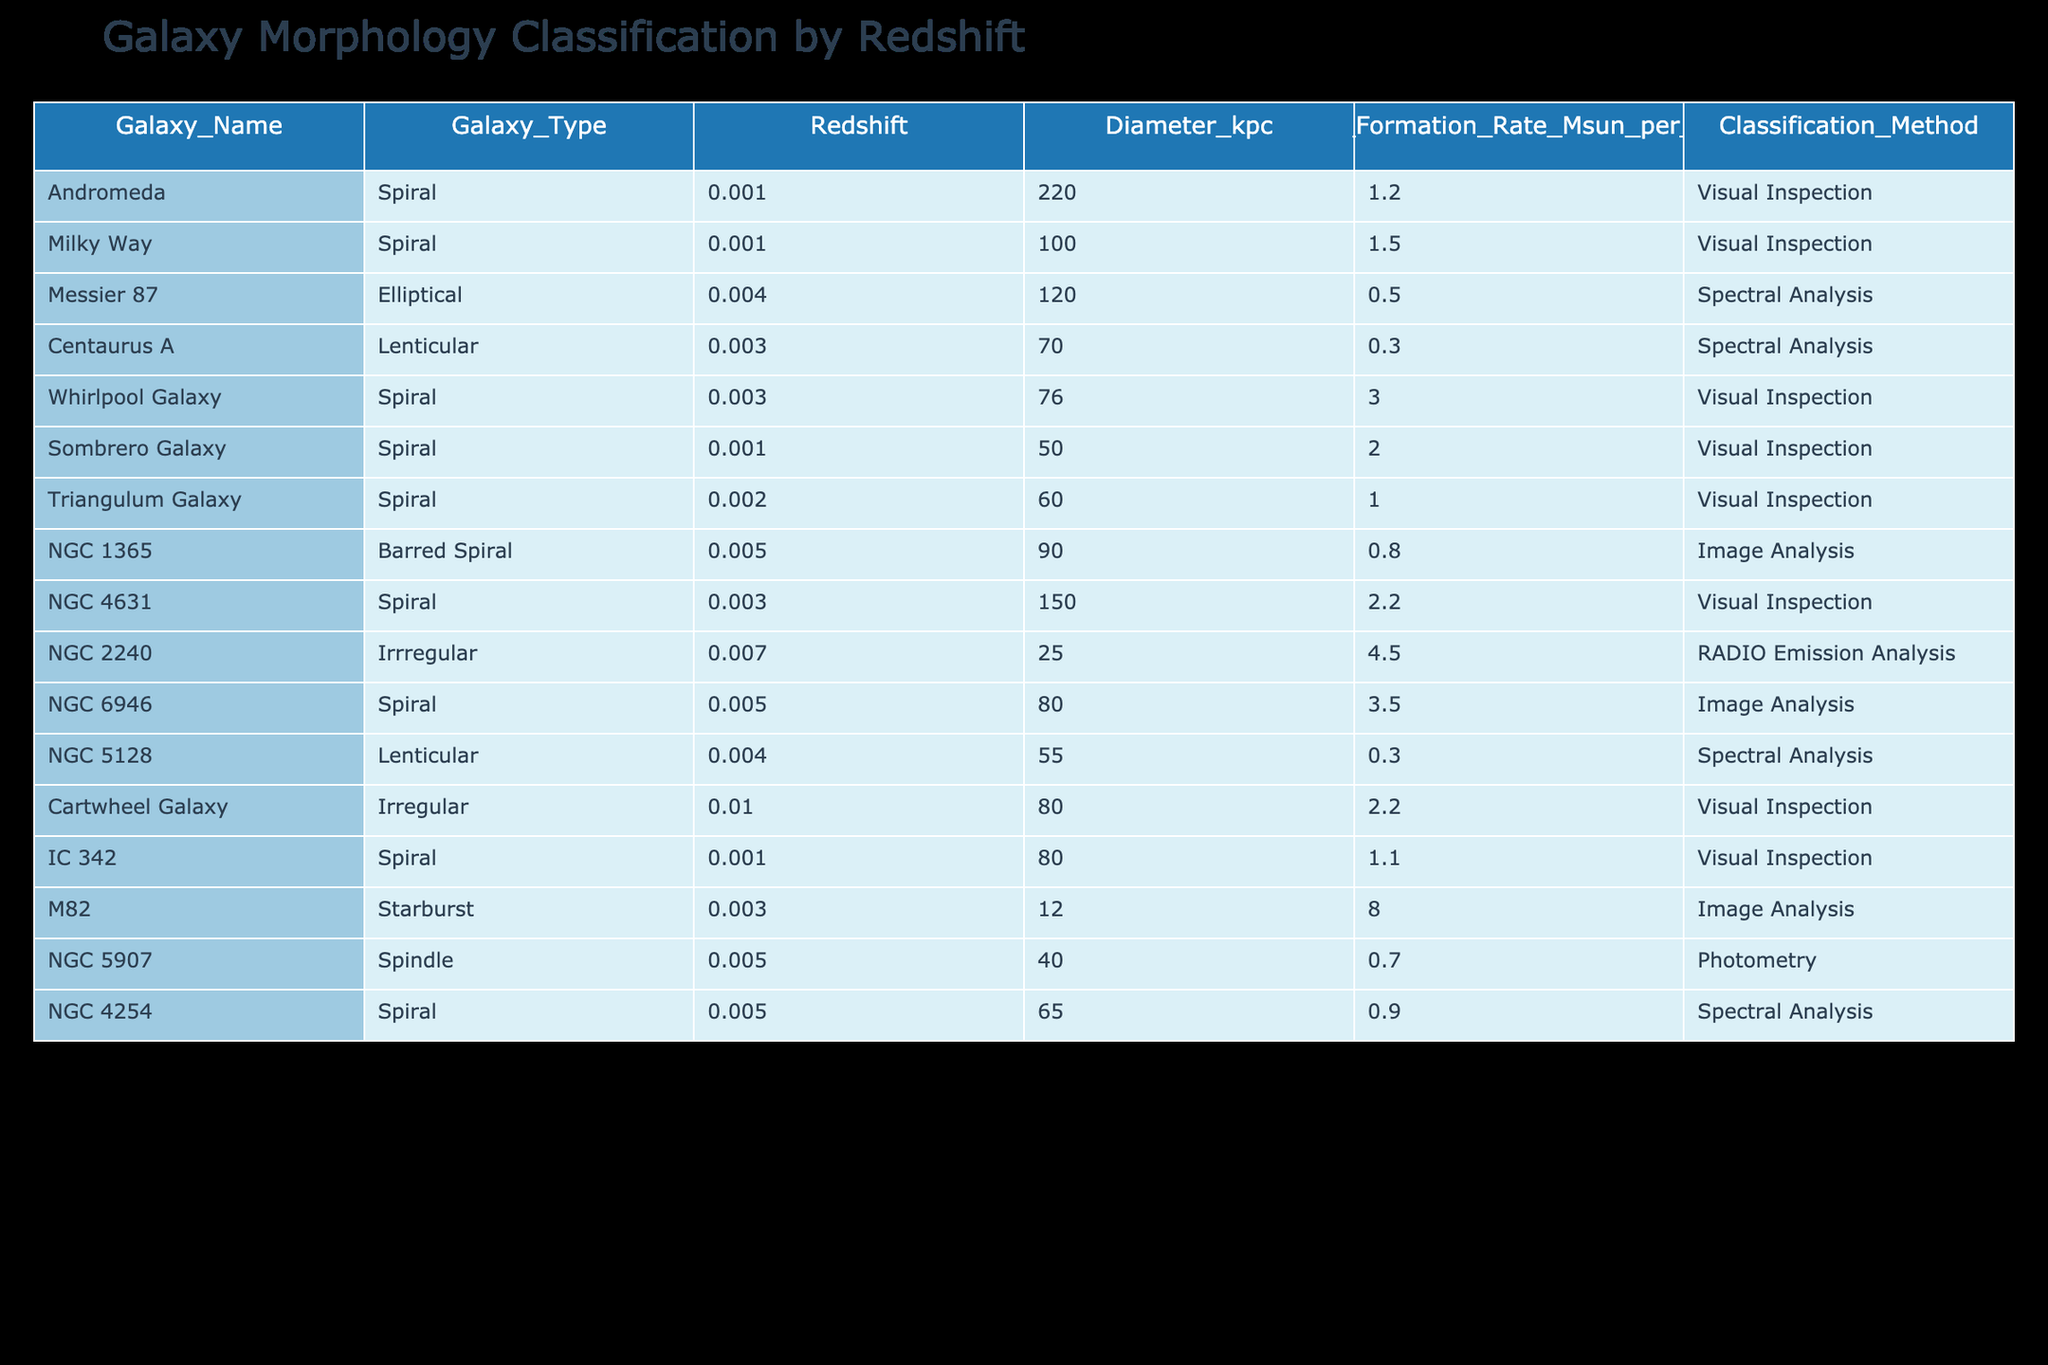What types of galaxies are present in the table? The table lists various galaxy types including Spiral, Elliptical, Lenticular, Barred Spiral, Irregular, Starburst, and Spindle. By scanning the 'Galaxy_Type' column, we can confirm these classifications.
Answer: Spiral, Elliptical, Lenticular, Barred Spiral, Irregular, Starburst, Spindle Which galaxy has the highest star formation rate? The 'Star_Formation_Rate_Msun_per_year' column shows the rates for each galaxy. By comparing the values, M82 with 8.0 has the highest star formation rate among the entries in the table.
Answer: M82 What is the average diameter of Spiral galaxies listed in the table? To determine this, we first gather the diameters of all Spiral galaxies (220, 100, 76, 60, 150, 80, 80, 65), which sums to 811. Since there are 8 Spiral galaxies, the average diameter is calculated as 811/8 = 101.375 kpc.
Answer: 101.375 kpc Is the Milky Way classified as a Starburst galaxy? By checking the 'Galaxy_Type' for the Milky Way, which is classified as 'Spiral', it confirms it is not categorized as a Starburst galaxy.
Answer: No How many galaxies have a redshift greater than 0.005? By scanning the 'Redshift' column, we find three galaxies with redshift values greater than 0.005: NGC 2240 (0.007), Cartwheel Galaxy (0.01), and M82 (0.003). That totals three galaxies exceeding the specified redshift.
Answer: 3 What is the total diameter of Lenticular galaxies? The diameters of the Lenticular galaxies Centaurus A (70 kpc) and NGC 5128 (55 kpc) sum up to 125 kpc (70 + 55). Thus, the total diameter of all Lenticulars listed is determined to be 125 kpc.
Answer: 125 kpc Is there any galaxy classified as Irregular that has a star formation rate greater than 2 Msun per year? Checking the 'Star_Formation_Rate_Msun_per_year' for the Irregular galaxies listed, NGC 2240 has 4.5 Msun per year, indicating that indeed there is one galaxy with a rate exceeding 2.
Answer: Yes Which classification method was used for NGC 6946? The table's 'Classification_Method' column indicates that NGC 6946 was classified using 'Image Analysis'. Thus, the specific method for this galaxy is identified directly from the table.
Answer: Image Analysis 